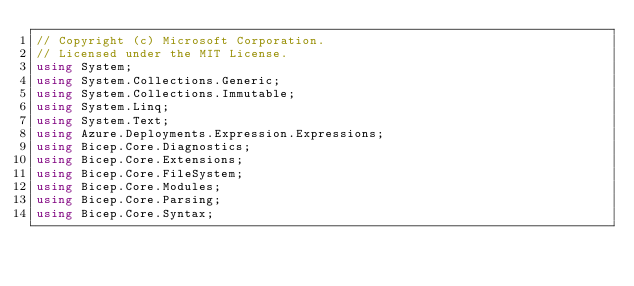<code> <loc_0><loc_0><loc_500><loc_500><_C#_>// Copyright (c) Microsoft Corporation.
// Licensed under the MIT License.
using System;
using System.Collections.Generic;
using System.Collections.Immutable;
using System.Linq;
using System.Text;
using Azure.Deployments.Expression.Expressions;
using Bicep.Core.Diagnostics;
using Bicep.Core.Extensions;
using Bicep.Core.FileSystem;
using Bicep.Core.Modules;
using Bicep.Core.Parsing;
using Bicep.Core.Syntax;</code> 